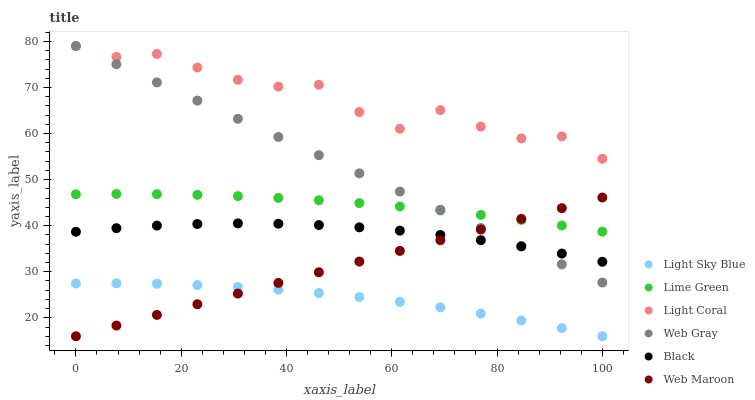Does Light Sky Blue have the minimum area under the curve?
Answer yes or no. Yes. Does Light Coral have the maximum area under the curve?
Answer yes or no. Yes. Does Web Maroon have the minimum area under the curve?
Answer yes or no. No. Does Web Maroon have the maximum area under the curve?
Answer yes or no. No. Is Web Maroon the smoothest?
Answer yes or no. Yes. Is Light Coral the roughest?
Answer yes or no. Yes. Is Light Coral the smoothest?
Answer yes or no. No. Is Web Maroon the roughest?
Answer yes or no. No. Does Web Maroon have the lowest value?
Answer yes or no. Yes. Does Light Coral have the lowest value?
Answer yes or no. No. Does Light Coral have the highest value?
Answer yes or no. Yes. Does Web Maroon have the highest value?
Answer yes or no. No. Is Light Sky Blue less than Black?
Answer yes or no. Yes. Is Light Coral greater than Black?
Answer yes or no. Yes. Does Light Sky Blue intersect Web Maroon?
Answer yes or no. Yes. Is Light Sky Blue less than Web Maroon?
Answer yes or no. No. Is Light Sky Blue greater than Web Maroon?
Answer yes or no. No. Does Light Sky Blue intersect Black?
Answer yes or no. No. 